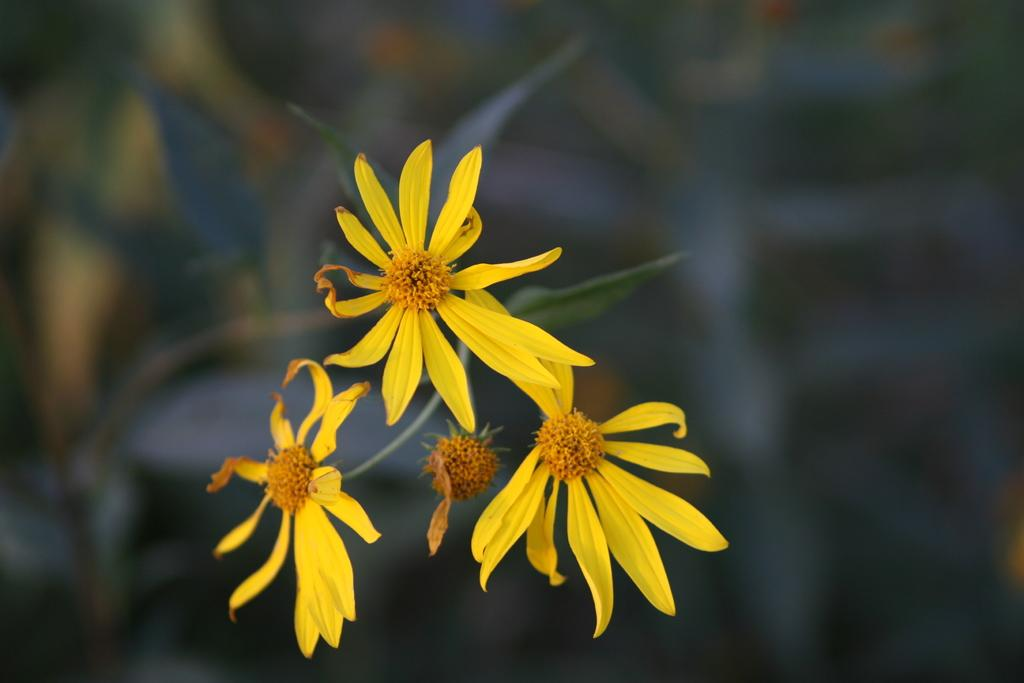What is in the foreground of the image? There are three flowers in the foreground of the image. Are the flowers part of a larger plant? Yes, the flowers are attached to a plant. What can be observed about the background of the image? The background of the image is blurred. What type of yam is growing next to the flowers in the image? There is no yam present in the image; it features three flowers attached to a plant. Can you see the pocket of the person taking the photo in the image? There is no person taking the photo in the image, and therefore no pocket is visible. 